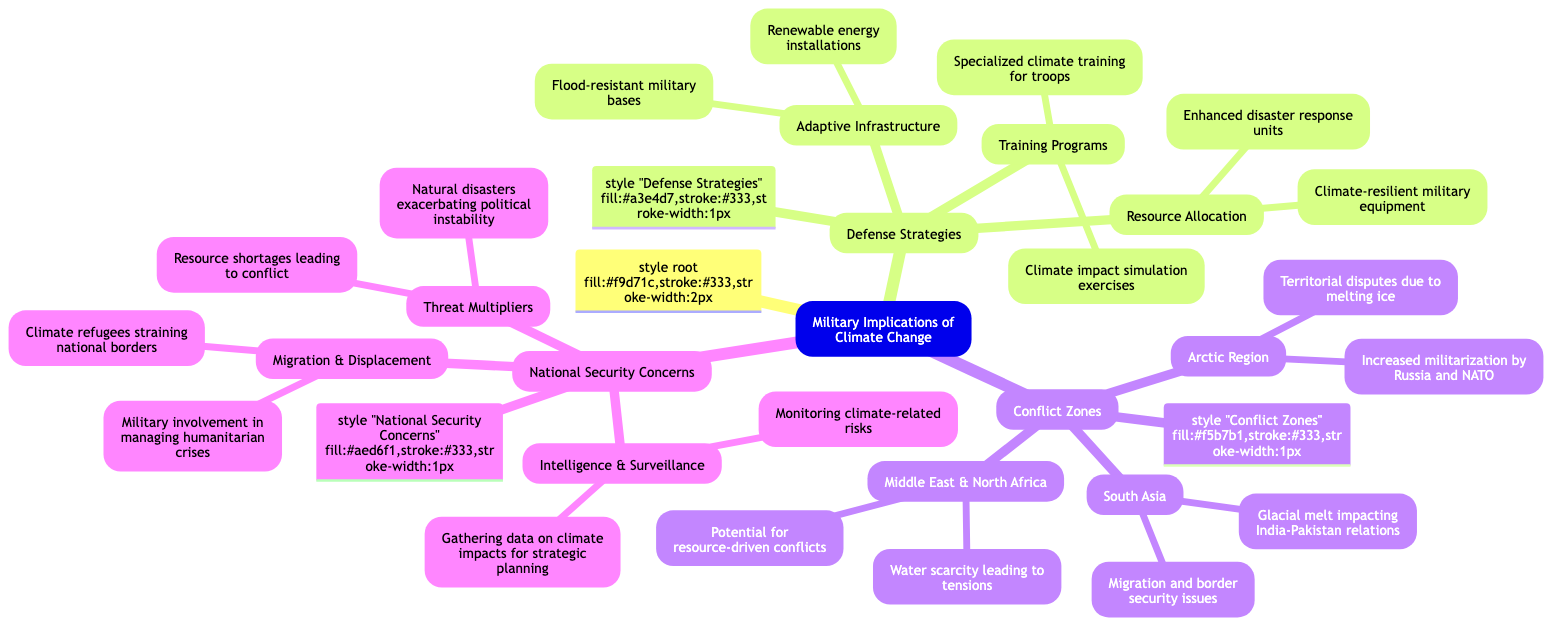What are two examples of adaptive infrastructure in the military context? The diagram under "Adaptive Infrastructure" lists "Flood-resistant military bases" and "Renewable energy installations" as examples.
Answer: Flood-resistant military bases, Renewable energy installations How many main categories are there in the diagram? The diagram consists of three main categories: "Defense Strategies," "Conflict Zones," and "National Security Concerns."
Answer: 3 What does "Resource Allocation" focus on within defense strategies? "Resource Allocation" under "Defense Strategies" includes "Climate-resilient military equipment" and "Enhanced disaster response units."
Answer: Climate-resilient military equipment, Enhanced disaster response units Which conflict zone is associated with water scarcity leading to tensions? The "Middle East & North Africa" under "Conflict Zones" is associated with "Water scarcity leading to tensions."
Answer: Middle East & North Africa What impact does glacial melt have on India-Pakistan relations? The diagram indicates that glacial melt affects relations between India and Pakistan by creating "Migration and border security issues."
Answer: Migration and border security issues What are climate refugees a concern for in national security? Under "Migration & Displacement," the diagram points out that climate refugees strain national borders, raising concerns for national security.
Answer: Climate refugees straining national borders Which category includes "Natural disasters exacerbating political instability"? This element is part of "Threat Multipliers" under the "National Security Concerns" category within the diagram.
Answer: Threat Multipliers What type of training is mentioned under "Training Programs"? The diagram specifies "Climate impact simulation exercises" and "Specialized climate training for troops" under "Training Programs."
Answer: Climate impact simulation exercises, Specialized climate training for troops What role does intelligence and surveillance play in national security with respect to climate change? The diagram lists "Monitoring climate-related risks" and "Gathering data on climate impacts for strategic planning," which outlines its role under "Intelligence & Surveillance."
Answer: Monitoring climate-related risks, Gathering data on climate impacts for strategic planning 